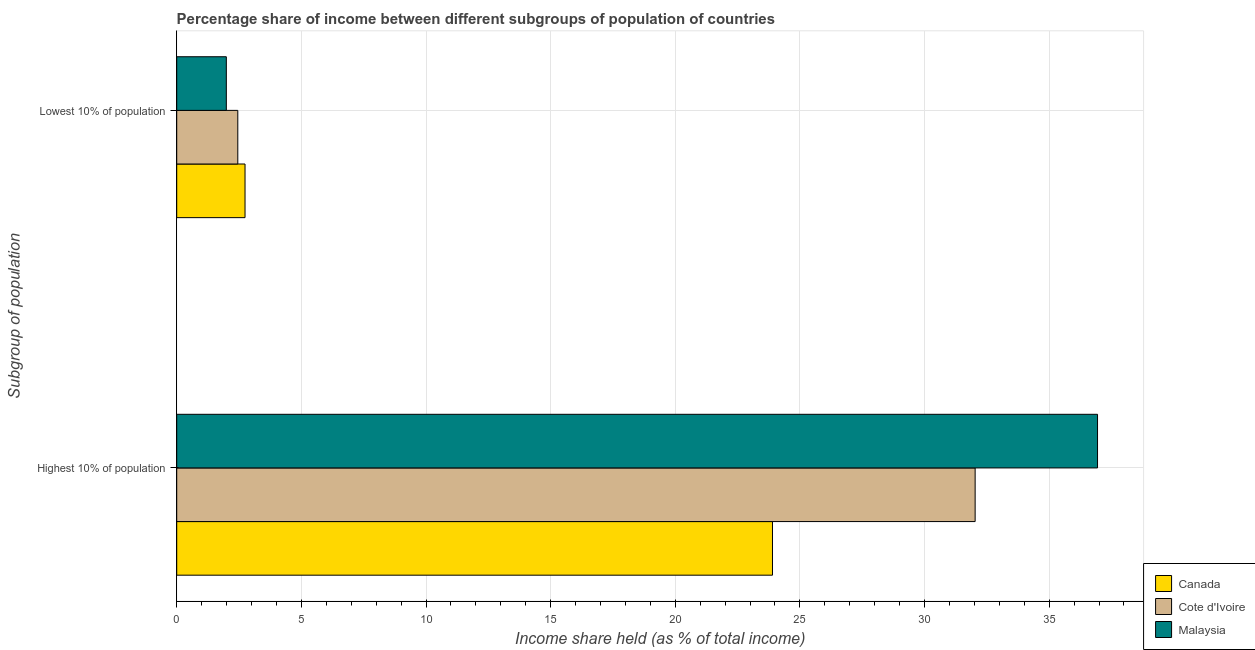How many different coloured bars are there?
Offer a terse response. 3. How many bars are there on the 2nd tick from the bottom?
Offer a terse response. 3. What is the label of the 2nd group of bars from the top?
Provide a succinct answer. Highest 10% of population. What is the income share held by highest 10% of the population in Cote d'Ivoire?
Your answer should be compact. 32.03. Across all countries, what is the maximum income share held by highest 10% of the population?
Provide a short and direct response. 36.94. Across all countries, what is the minimum income share held by highest 10% of the population?
Your answer should be very brief. 23.9. In which country was the income share held by highest 10% of the population minimum?
Your answer should be very brief. Canada. What is the total income share held by lowest 10% of the population in the graph?
Provide a succinct answer. 7.18. What is the difference between the income share held by lowest 10% of the population in Malaysia and that in Canada?
Your answer should be compact. -0.75. What is the difference between the income share held by lowest 10% of the population in Canada and the income share held by highest 10% of the population in Malaysia?
Offer a terse response. -34.2. What is the average income share held by highest 10% of the population per country?
Provide a short and direct response. 30.96. What is the difference between the income share held by lowest 10% of the population and income share held by highest 10% of the population in Cote d'Ivoire?
Provide a short and direct response. -29.58. In how many countries, is the income share held by lowest 10% of the population greater than 33 %?
Your answer should be very brief. 0. What is the ratio of the income share held by lowest 10% of the population in Cote d'Ivoire to that in Canada?
Offer a very short reply. 0.89. In how many countries, is the income share held by highest 10% of the population greater than the average income share held by highest 10% of the population taken over all countries?
Ensure brevity in your answer.  2. What does the 2nd bar from the bottom in Lowest 10% of population represents?
Ensure brevity in your answer.  Cote d'Ivoire. Are all the bars in the graph horizontal?
Offer a very short reply. Yes. Are the values on the major ticks of X-axis written in scientific E-notation?
Give a very brief answer. No. How are the legend labels stacked?
Offer a terse response. Vertical. What is the title of the graph?
Offer a very short reply. Percentage share of income between different subgroups of population of countries. What is the label or title of the X-axis?
Give a very brief answer. Income share held (as % of total income). What is the label or title of the Y-axis?
Make the answer very short. Subgroup of population. What is the Income share held (as % of total income) in Canada in Highest 10% of population?
Offer a terse response. 23.9. What is the Income share held (as % of total income) in Cote d'Ivoire in Highest 10% of population?
Give a very brief answer. 32.03. What is the Income share held (as % of total income) of Malaysia in Highest 10% of population?
Ensure brevity in your answer.  36.94. What is the Income share held (as % of total income) in Canada in Lowest 10% of population?
Your answer should be very brief. 2.74. What is the Income share held (as % of total income) in Cote d'Ivoire in Lowest 10% of population?
Provide a succinct answer. 2.45. What is the Income share held (as % of total income) of Malaysia in Lowest 10% of population?
Offer a very short reply. 1.99. Across all Subgroup of population, what is the maximum Income share held (as % of total income) in Canada?
Offer a very short reply. 23.9. Across all Subgroup of population, what is the maximum Income share held (as % of total income) in Cote d'Ivoire?
Your answer should be compact. 32.03. Across all Subgroup of population, what is the maximum Income share held (as % of total income) of Malaysia?
Make the answer very short. 36.94. Across all Subgroup of population, what is the minimum Income share held (as % of total income) in Canada?
Offer a very short reply. 2.74. Across all Subgroup of population, what is the minimum Income share held (as % of total income) in Cote d'Ivoire?
Offer a terse response. 2.45. Across all Subgroup of population, what is the minimum Income share held (as % of total income) of Malaysia?
Provide a succinct answer. 1.99. What is the total Income share held (as % of total income) in Canada in the graph?
Ensure brevity in your answer.  26.64. What is the total Income share held (as % of total income) in Cote d'Ivoire in the graph?
Your answer should be very brief. 34.48. What is the total Income share held (as % of total income) in Malaysia in the graph?
Provide a succinct answer. 38.93. What is the difference between the Income share held (as % of total income) in Canada in Highest 10% of population and that in Lowest 10% of population?
Provide a succinct answer. 21.16. What is the difference between the Income share held (as % of total income) of Cote d'Ivoire in Highest 10% of population and that in Lowest 10% of population?
Provide a succinct answer. 29.58. What is the difference between the Income share held (as % of total income) in Malaysia in Highest 10% of population and that in Lowest 10% of population?
Ensure brevity in your answer.  34.95. What is the difference between the Income share held (as % of total income) in Canada in Highest 10% of population and the Income share held (as % of total income) in Cote d'Ivoire in Lowest 10% of population?
Ensure brevity in your answer.  21.45. What is the difference between the Income share held (as % of total income) of Canada in Highest 10% of population and the Income share held (as % of total income) of Malaysia in Lowest 10% of population?
Keep it short and to the point. 21.91. What is the difference between the Income share held (as % of total income) of Cote d'Ivoire in Highest 10% of population and the Income share held (as % of total income) of Malaysia in Lowest 10% of population?
Keep it short and to the point. 30.04. What is the average Income share held (as % of total income) in Canada per Subgroup of population?
Provide a short and direct response. 13.32. What is the average Income share held (as % of total income) in Cote d'Ivoire per Subgroup of population?
Your answer should be very brief. 17.24. What is the average Income share held (as % of total income) of Malaysia per Subgroup of population?
Provide a short and direct response. 19.46. What is the difference between the Income share held (as % of total income) of Canada and Income share held (as % of total income) of Cote d'Ivoire in Highest 10% of population?
Your answer should be very brief. -8.13. What is the difference between the Income share held (as % of total income) of Canada and Income share held (as % of total income) of Malaysia in Highest 10% of population?
Your answer should be very brief. -13.04. What is the difference between the Income share held (as % of total income) of Cote d'Ivoire and Income share held (as % of total income) of Malaysia in Highest 10% of population?
Make the answer very short. -4.91. What is the difference between the Income share held (as % of total income) of Canada and Income share held (as % of total income) of Cote d'Ivoire in Lowest 10% of population?
Offer a terse response. 0.29. What is the difference between the Income share held (as % of total income) in Cote d'Ivoire and Income share held (as % of total income) in Malaysia in Lowest 10% of population?
Your answer should be very brief. 0.46. What is the ratio of the Income share held (as % of total income) of Canada in Highest 10% of population to that in Lowest 10% of population?
Keep it short and to the point. 8.72. What is the ratio of the Income share held (as % of total income) of Cote d'Ivoire in Highest 10% of population to that in Lowest 10% of population?
Your answer should be very brief. 13.07. What is the ratio of the Income share held (as % of total income) of Malaysia in Highest 10% of population to that in Lowest 10% of population?
Your answer should be compact. 18.56. What is the difference between the highest and the second highest Income share held (as % of total income) in Canada?
Offer a terse response. 21.16. What is the difference between the highest and the second highest Income share held (as % of total income) in Cote d'Ivoire?
Give a very brief answer. 29.58. What is the difference between the highest and the second highest Income share held (as % of total income) in Malaysia?
Your answer should be very brief. 34.95. What is the difference between the highest and the lowest Income share held (as % of total income) of Canada?
Offer a terse response. 21.16. What is the difference between the highest and the lowest Income share held (as % of total income) in Cote d'Ivoire?
Your answer should be compact. 29.58. What is the difference between the highest and the lowest Income share held (as % of total income) in Malaysia?
Make the answer very short. 34.95. 